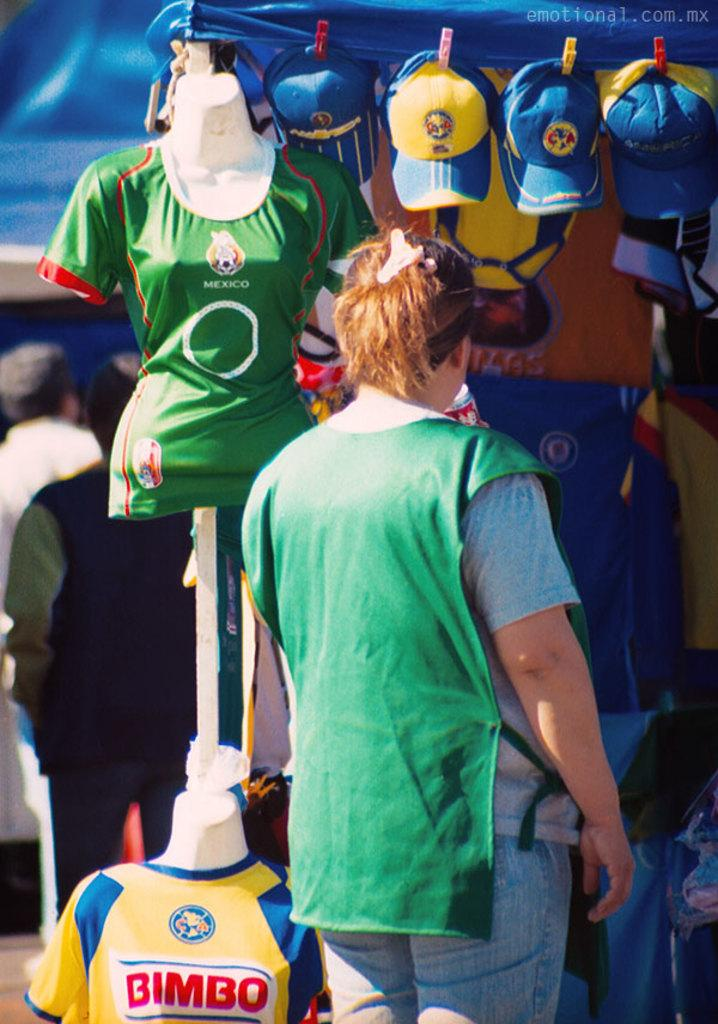Provide a one-sentence caption for the provided image. A woman checks out several jerseys including ones advertising the snack food brand Bimbo. 